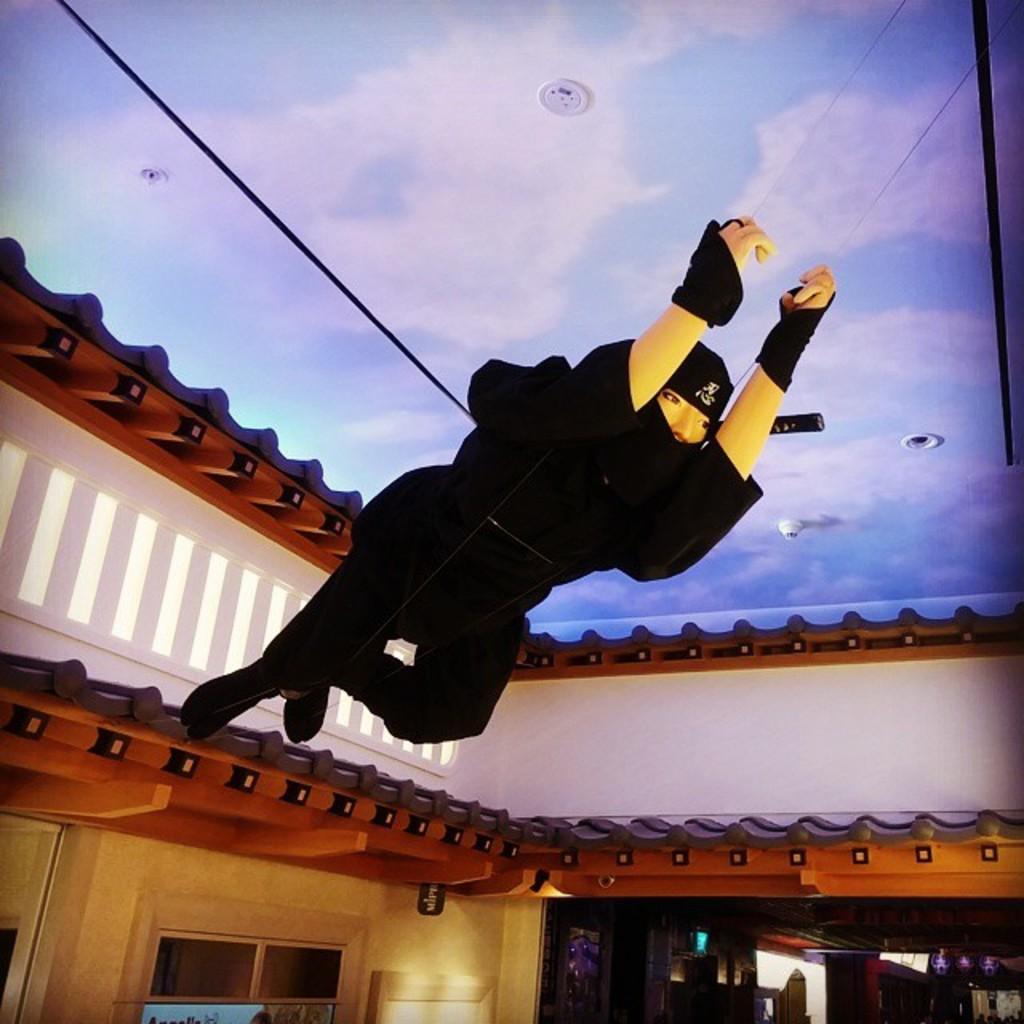Could you give a brief overview of what you see in this image? This image is taken indoors. At the top of the image there is a roof with paintings. In the background there are a few walls. There are a few carvings on the walls. There is a board with a text on it. In the middle of the image there is a statue of a human tied with ropes. 